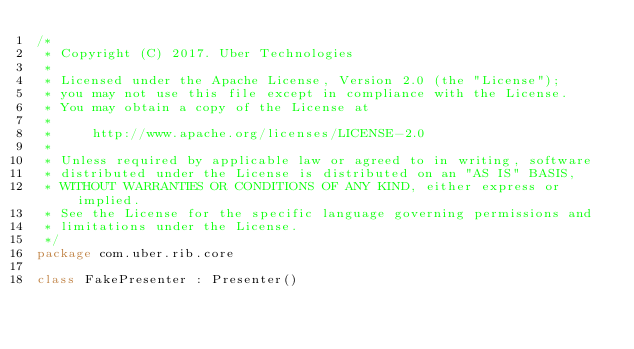<code> <loc_0><loc_0><loc_500><loc_500><_Kotlin_>/*
 * Copyright (C) 2017. Uber Technologies
 *
 * Licensed under the Apache License, Version 2.0 (the "License");
 * you may not use this file except in compliance with the License.
 * You may obtain a copy of the License at
 *
 *     http://www.apache.org/licenses/LICENSE-2.0
 *
 * Unless required by applicable law or agreed to in writing, software
 * distributed under the License is distributed on an "AS IS" BASIS,
 * WITHOUT WARRANTIES OR CONDITIONS OF ANY KIND, either express or implied.
 * See the License for the specific language governing permissions and
 * limitations under the License.
 */
package com.uber.rib.core

class FakePresenter : Presenter()
</code> 